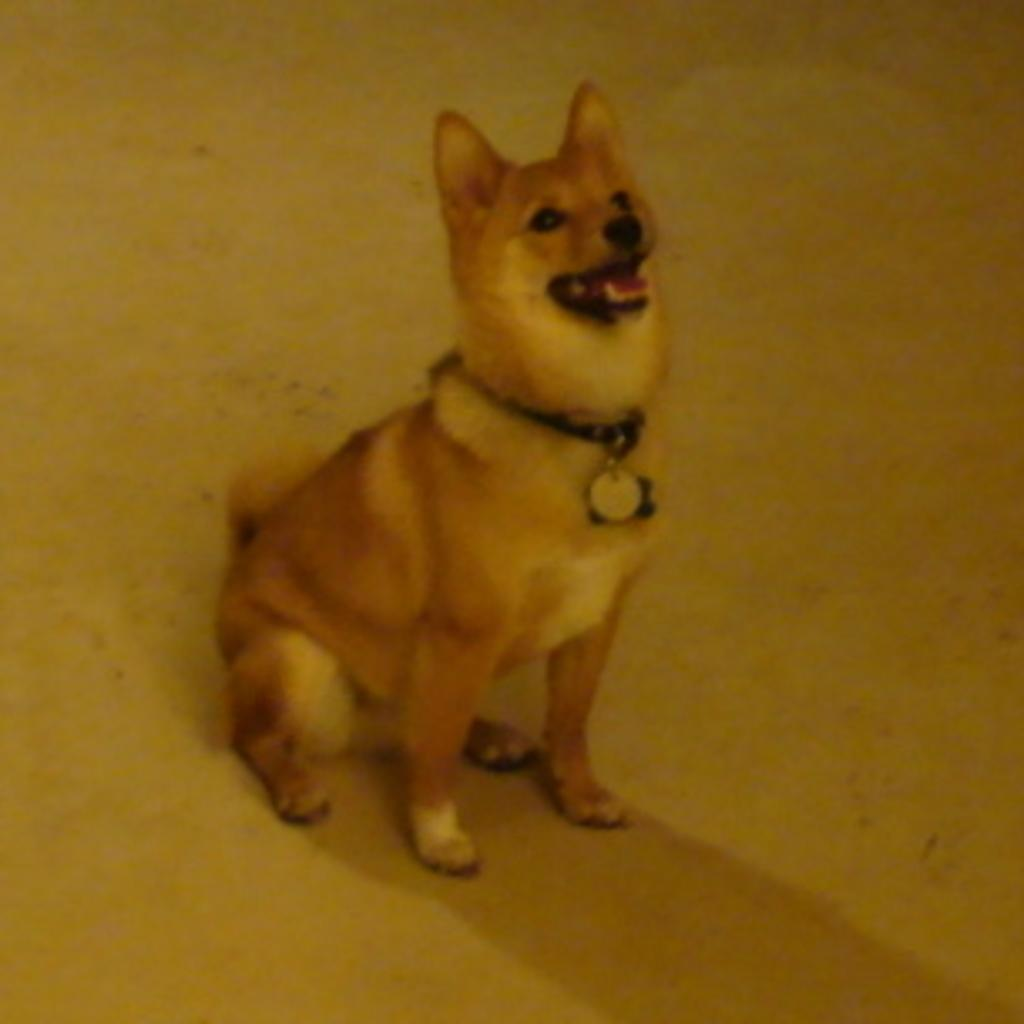What animal can be seen in the image? There is a dog in the image. What is the dog doing in the image? The dog is sitting on the floor. How is the dog secured in the image? The dog is tied with a belt. What additional detail can be observed about the belt? The belt has a locket attached to it. What language does the lawyer use to communicate with the dog in the image? There is no lawyer present in the image, and therefore no communication between a lawyer and the dog can be observed. 